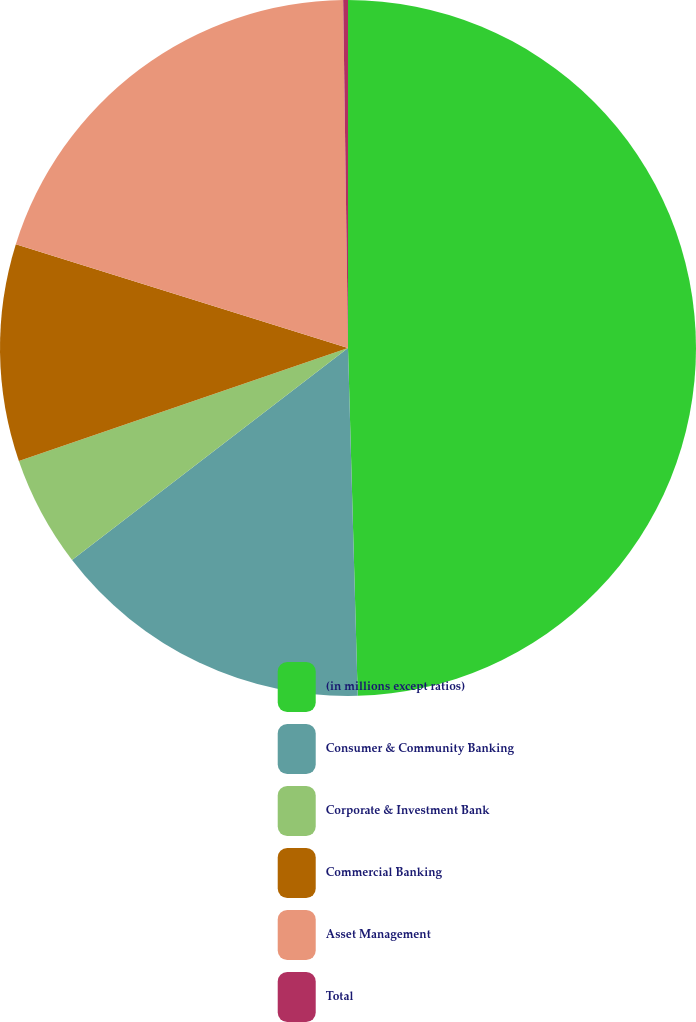<chart> <loc_0><loc_0><loc_500><loc_500><pie_chart><fcel>(in millions except ratios)<fcel>Consumer & Community Banking<fcel>Corporate & Investment Bank<fcel>Commercial Banking<fcel>Asset Management<fcel>Total<nl><fcel>49.56%<fcel>15.02%<fcel>5.16%<fcel>10.09%<fcel>19.96%<fcel>0.22%<nl></chart> 